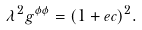Convert formula to latex. <formula><loc_0><loc_0><loc_500><loc_500>\lambda ^ { 2 } g ^ { \phi \phi } = ( 1 + e c ) ^ { 2 } .</formula> 